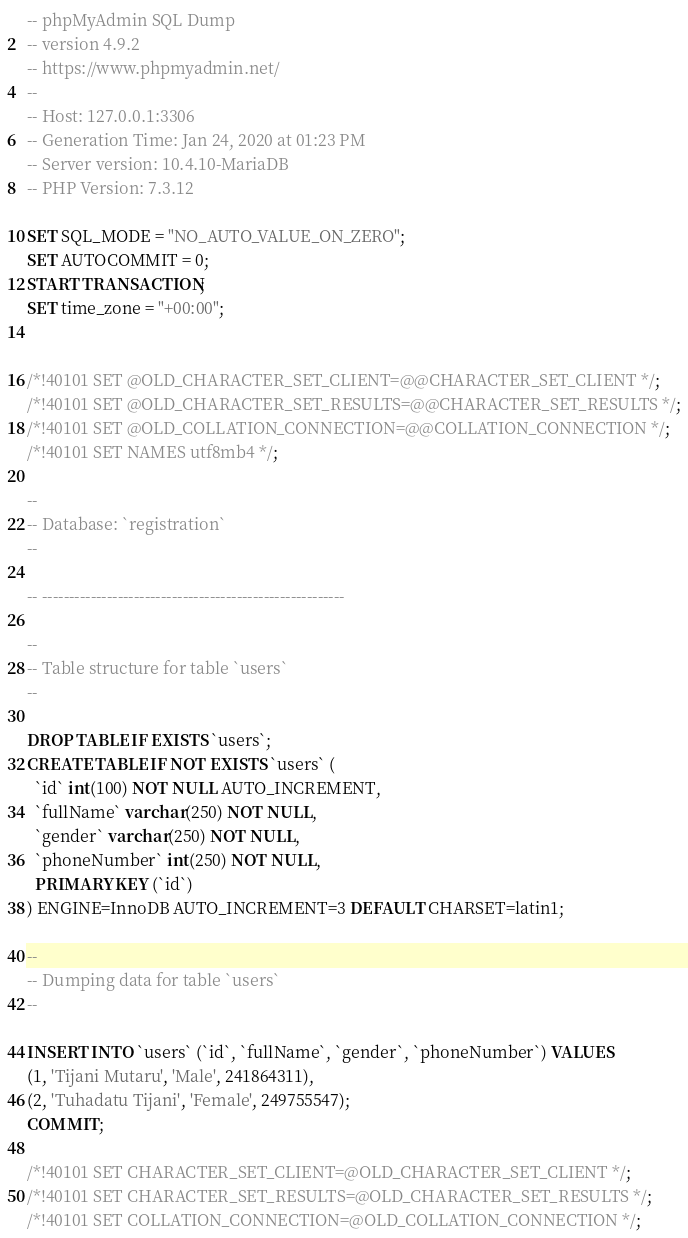<code> <loc_0><loc_0><loc_500><loc_500><_SQL_>-- phpMyAdmin SQL Dump
-- version 4.9.2
-- https://www.phpmyadmin.net/
--
-- Host: 127.0.0.1:3306
-- Generation Time: Jan 24, 2020 at 01:23 PM
-- Server version: 10.4.10-MariaDB
-- PHP Version: 7.3.12

SET SQL_MODE = "NO_AUTO_VALUE_ON_ZERO";
SET AUTOCOMMIT = 0;
START TRANSACTION;
SET time_zone = "+00:00";


/*!40101 SET @OLD_CHARACTER_SET_CLIENT=@@CHARACTER_SET_CLIENT */;
/*!40101 SET @OLD_CHARACTER_SET_RESULTS=@@CHARACTER_SET_RESULTS */;
/*!40101 SET @OLD_COLLATION_CONNECTION=@@COLLATION_CONNECTION */;
/*!40101 SET NAMES utf8mb4 */;

--
-- Database: `registration`
--

-- --------------------------------------------------------

--
-- Table structure for table `users`
--

DROP TABLE IF EXISTS `users`;
CREATE TABLE IF NOT EXISTS `users` (
  `id` int(100) NOT NULL AUTO_INCREMENT,
  `fullName` varchar(250) NOT NULL,
  `gender` varchar(250) NOT NULL,
  `phoneNumber` int(250) NOT NULL,
  PRIMARY KEY (`id`)
) ENGINE=InnoDB AUTO_INCREMENT=3 DEFAULT CHARSET=latin1;

--
-- Dumping data for table `users`
--

INSERT INTO `users` (`id`, `fullName`, `gender`, `phoneNumber`) VALUES
(1, 'Tijani Mutaru', 'Male', 241864311),
(2, 'Tuhadatu Tijani', 'Female', 249755547);
COMMIT;

/*!40101 SET CHARACTER_SET_CLIENT=@OLD_CHARACTER_SET_CLIENT */;
/*!40101 SET CHARACTER_SET_RESULTS=@OLD_CHARACTER_SET_RESULTS */;
/*!40101 SET COLLATION_CONNECTION=@OLD_COLLATION_CONNECTION */;
</code> 